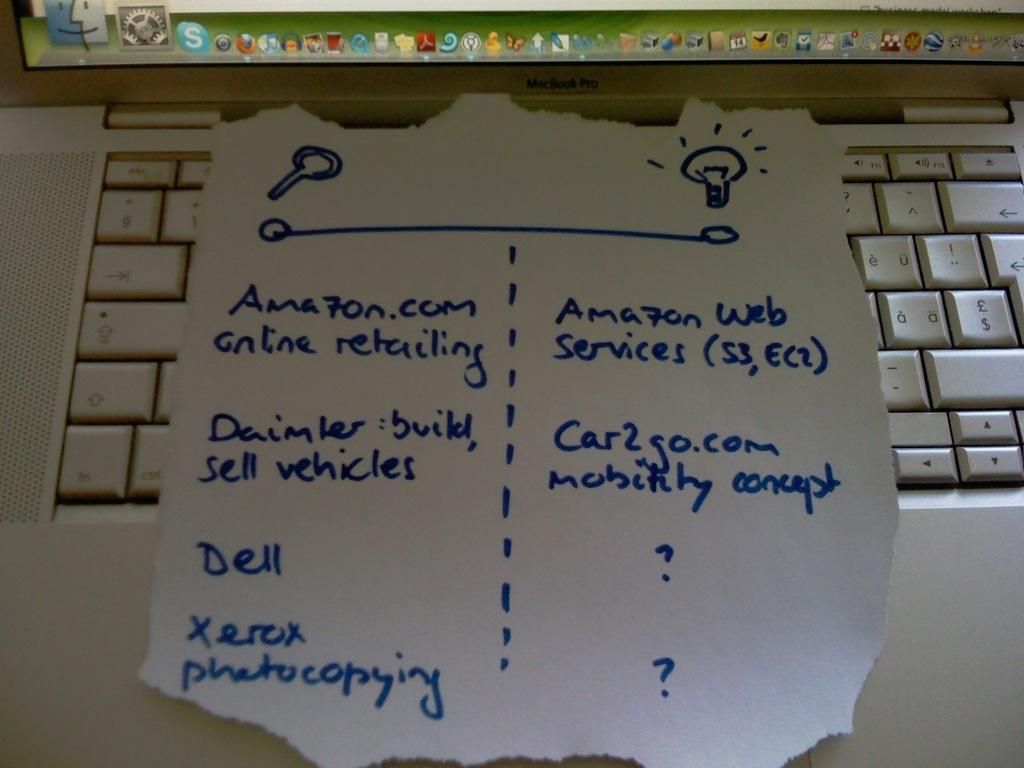Provide a one-sentence caption for the provided image. A blue, hand written list includes the Amazon website. 